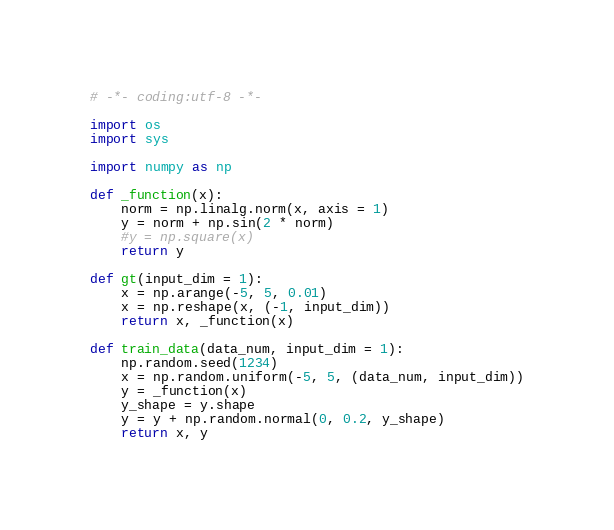Convert code to text. <code><loc_0><loc_0><loc_500><loc_500><_Python_># -*- coding:utf-8 -*-

import os
import sys

import numpy as np

def _function(x):
    norm = np.linalg.norm(x, axis = 1)
    y = norm + np.sin(2 * norm)
    #y = np.square(x)
    return y

def gt(input_dim = 1):
    x = np.arange(-5, 5, 0.01)
    x = np.reshape(x, (-1, input_dim))
    return x, _function(x)

def train_data(data_num, input_dim = 1):
    np.random.seed(1234)
    x = np.random.uniform(-5, 5, (data_num, input_dim))
    y = _function(x)
    y_shape = y.shape
    y = y + np.random.normal(0, 0.2, y_shape)
    return x, y
</code> 